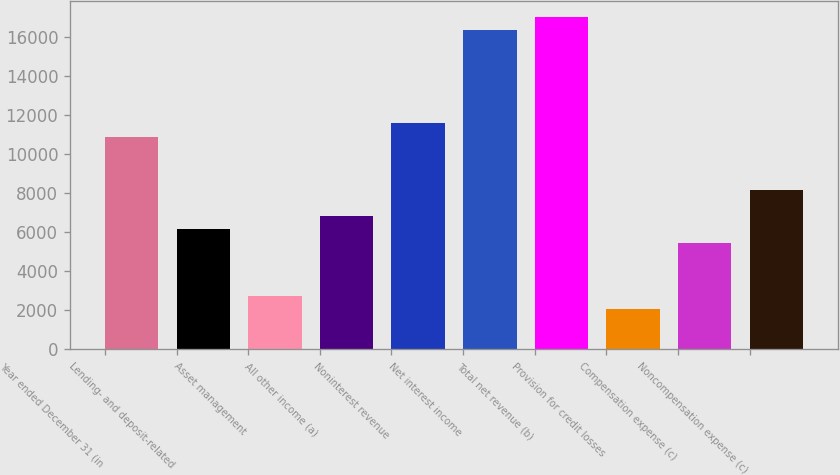<chart> <loc_0><loc_0><loc_500><loc_500><bar_chart><fcel>Year ended December 31 (in<fcel>Lending- and deposit-related<fcel>Asset management<fcel>All other income (a)<fcel>Noninterest revenue<fcel>Net interest income<fcel>Total net revenue (b)<fcel>Provision for credit losses<fcel>Compensation expense (c)<fcel>Noncompensation expense (c)<nl><fcel>10903.8<fcel>6145.2<fcel>2746.2<fcel>6825<fcel>11583.6<fcel>16342.2<fcel>17022<fcel>2066.4<fcel>5465.4<fcel>8184.6<nl></chart> 